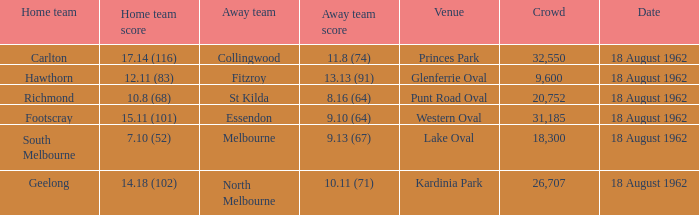At what venue where the home team scored 12.11 (83) was the crowd larger than 31,185? None. 